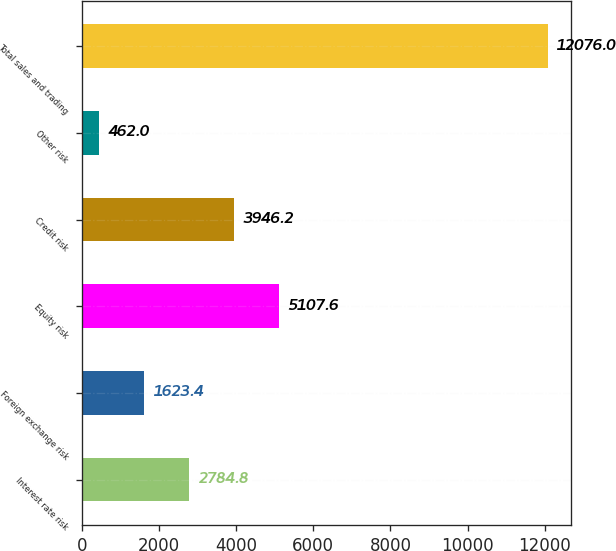Convert chart. <chart><loc_0><loc_0><loc_500><loc_500><bar_chart><fcel>Interest rate risk<fcel>Foreign exchange risk<fcel>Equity risk<fcel>Credit risk<fcel>Other risk<fcel>Total sales and trading<nl><fcel>2784.8<fcel>1623.4<fcel>5107.6<fcel>3946.2<fcel>462<fcel>12076<nl></chart> 